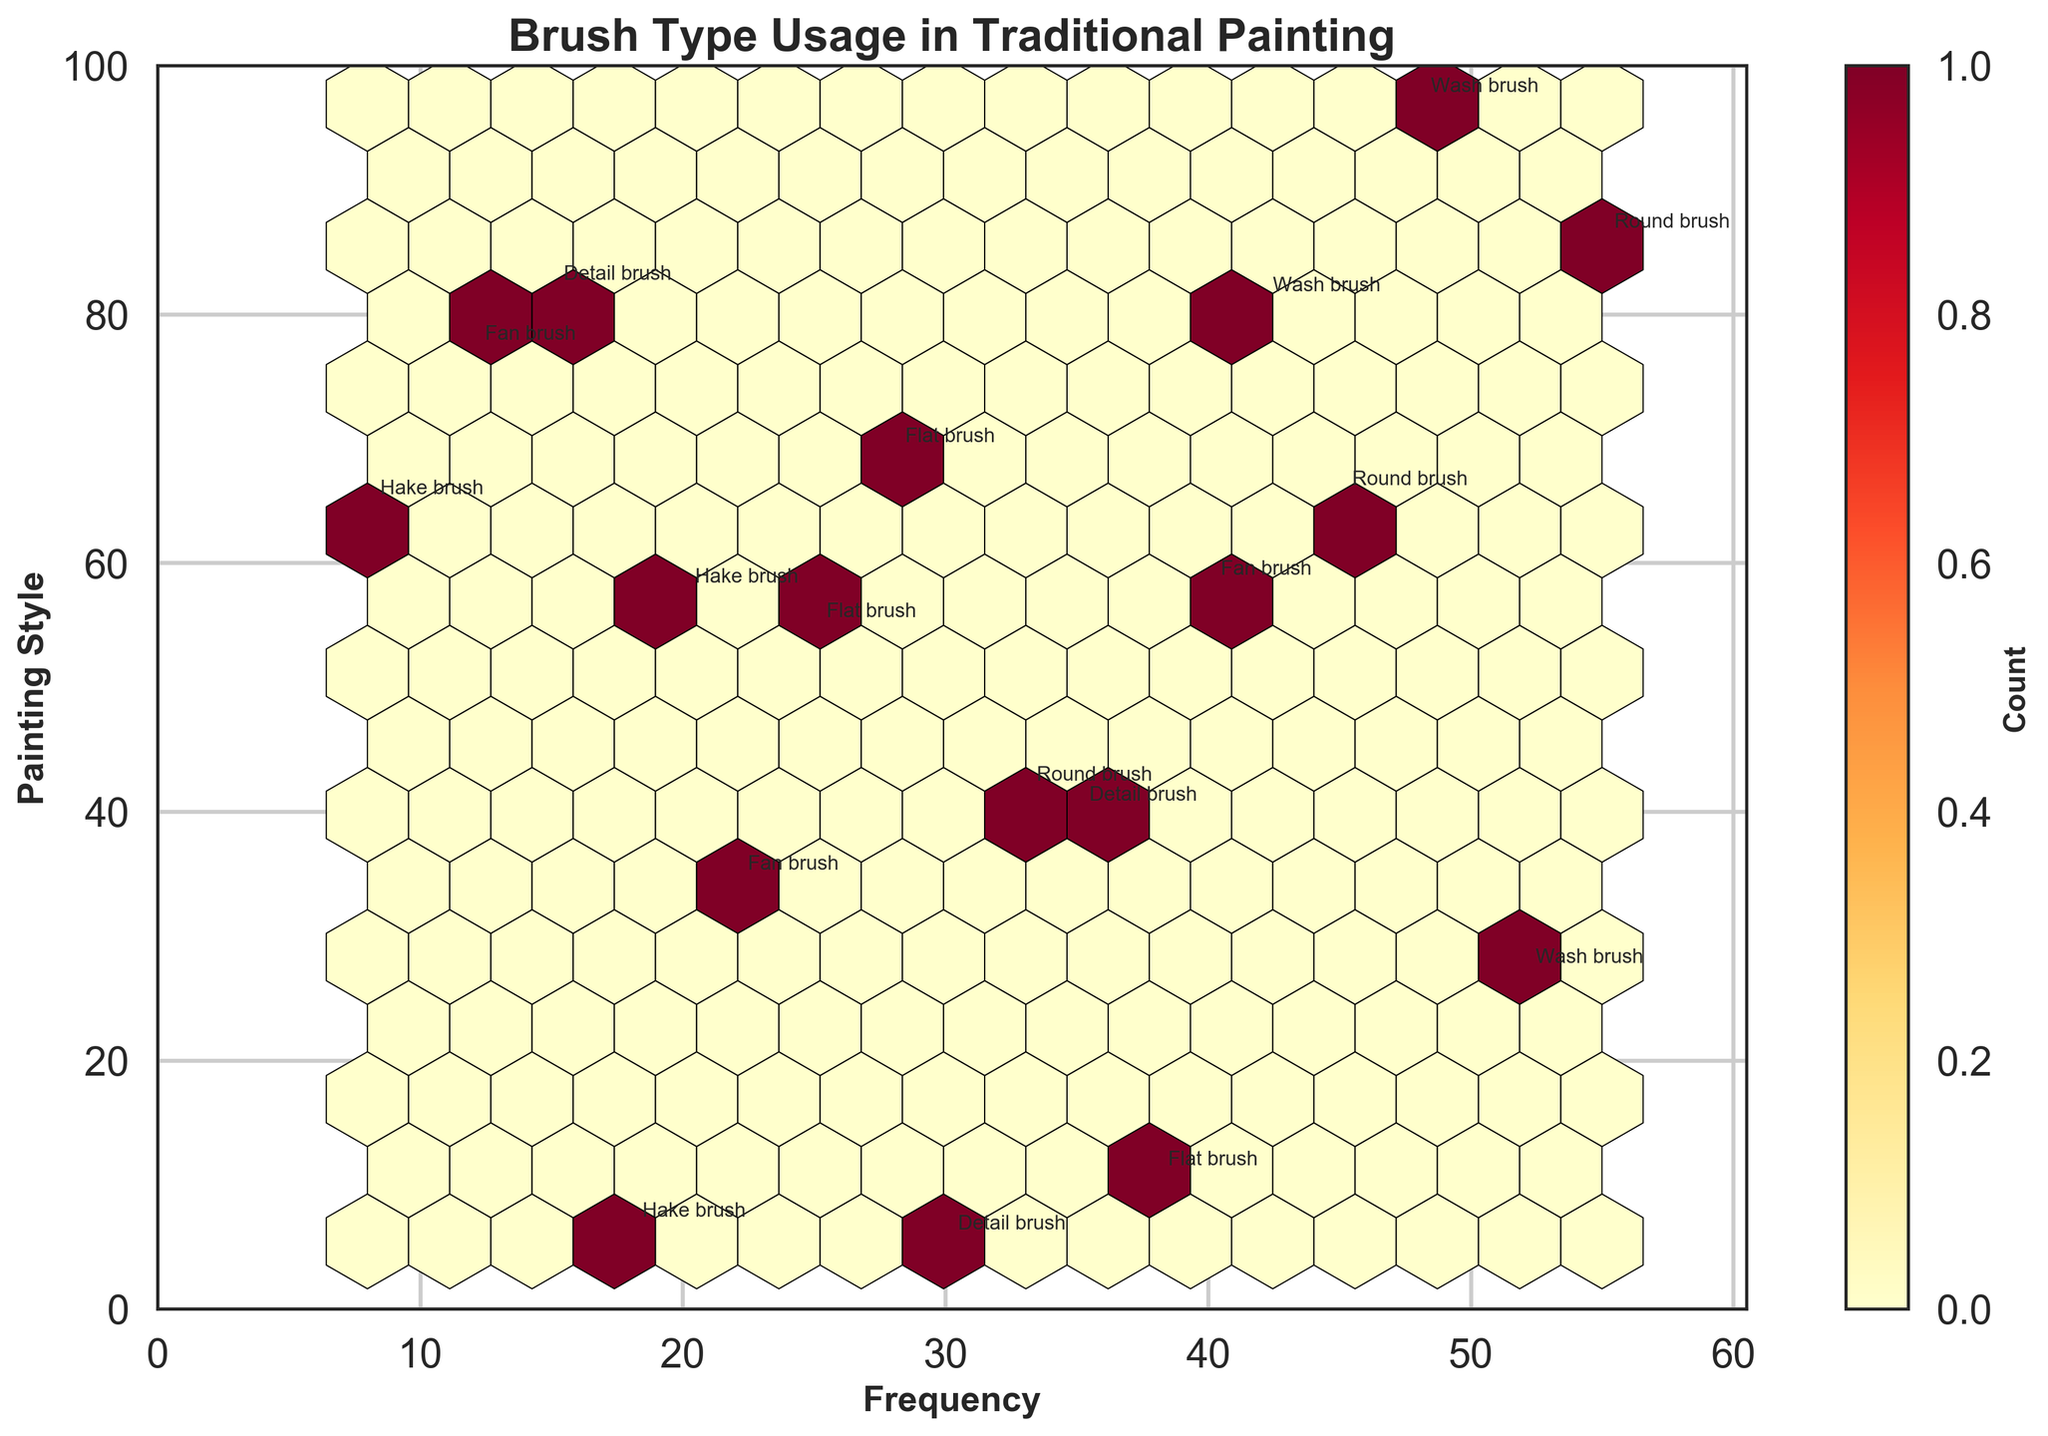What is the title of the hexbin plot? The title of a plot is usually located at the top center. According to the figure provided, the title is clearly stated.
Answer: Brush Type Usage in Traditional Painting What does the color scale in the hexbin plot represent? The color scale of a hexbin plot typically shows the density of data points in a bin. Here, the color bar on the right indicates the count of data points within each hexagon.
Answer: Count What range does the 'Frequency' axis cover? The x-axis represents frequency and usually has markers showing the minimum and maximum values. From the figure, it ranges from 0 to slightly above 60.
Answer: 0 to around 60 Which brush type is annotated near the highest frequency? By locating the annotation closest to the highest value on the x-axis, we see that "Round Brush" is near the frequency of 55.
Answer: Round brush How many hexagons are displayed in the plot? Count the number of hexagons formed in the grid. This represents the number of bins displayed. There are approximately 15 hexagons in the plot.
Answer: Approximately 15 Which brush type has the lowest frequency but still used across the regions shown? Identify the brush type marked on the plot with the lowest x-axis value. "Hake Brush" is closest to the origin with a frequency of 8.
Answer: Hake brush Compare the frequency usage of the 'Wash brush' and 'Detail brush.' Which has a higher usage frequency, and by how much? Find the x-axis values for both types. The Wash brush values are around 52 and 48, while Detail brush values are 15 and 30, making the highest frequency Wash brush 52 and Detail brush 30. The difference is 52 - 30 = 22.
Answer: Wash brush by 22 What is the median frequency of the data points? List all the frequency values, sort them, and find the middle value. The frequencies are 8, 12, 15, 18, 20, 22, 25, 28, 30, 33, 35, 38, 40, 42, 45, 48, 52, 55; the median is (30+33)/2 = 31.5.
Answer: 31.5 Why might some hexagons have darker shades than others? Darker hexagons represent a higher count of data points within those bins, indicating regions where brush types have similar usage frequencies.
Answer: Higher data point density Are there more data points in the lower or higher frequency ranges? Evaluate the plot by observing the density and distribution of hexagons. More data points are present in the range of 20-55 (higher frequency).
Answer: Higher frequency ranges 